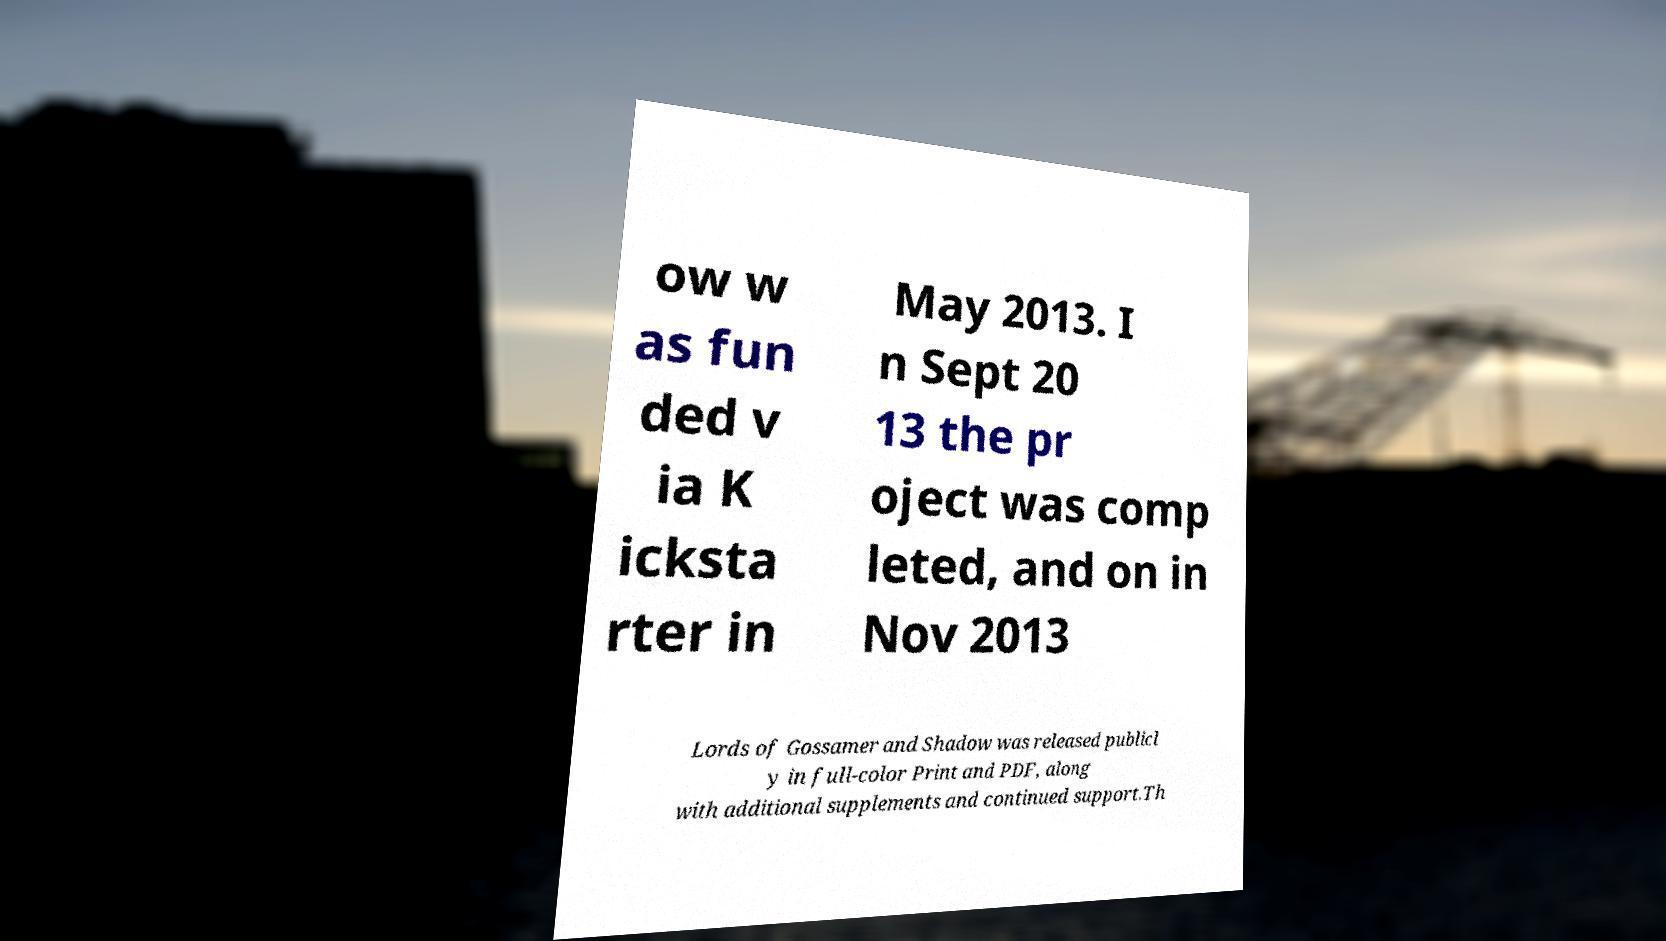For documentation purposes, I need the text within this image transcribed. Could you provide that? ow w as fun ded v ia K icksta rter in May 2013. I n Sept 20 13 the pr oject was comp leted, and on in Nov 2013 Lords of Gossamer and Shadow was released publicl y in full-color Print and PDF, along with additional supplements and continued support.Th 